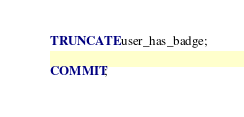<code> <loc_0><loc_0><loc_500><loc_500><_SQL_>
TRUNCATE user_has_badge;

COMMIT;
</code> 